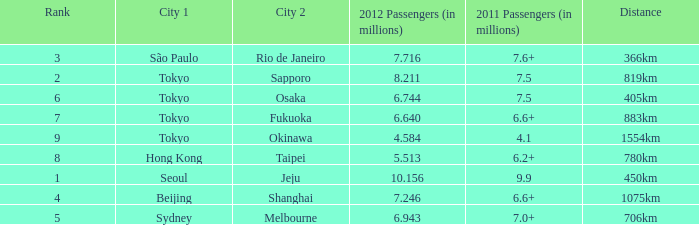What the is the first city listed on the route that had 6.6+ passengers in 2011 and a distance of 1075km? Beijing. 